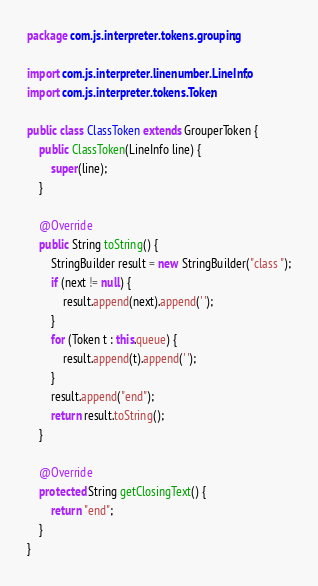<code> <loc_0><loc_0><loc_500><loc_500><_Java_>package com.js.interpreter.tokens.grouping;

import com.js.interpreter.linenumber.LineInfo;
import com.js.interpreter.tokens.Token;

public class ClassToken extends GrouperToken {
    public ClassToken(LineInfo line) {
        super(line);
    }

    @Override
    public String toString() {
        StringBuilder result = new StringBuilder("class ");
        if (next != null) {
            result.append(next).append(' ');
        }
        for (Token t : this.queue) {
            result.append(t).append(' ');
        }
        result.append("end");
        return result.toString();
    }

    @Override
    protected String getClosingText() {
        return "end";
    }
}
</code> 